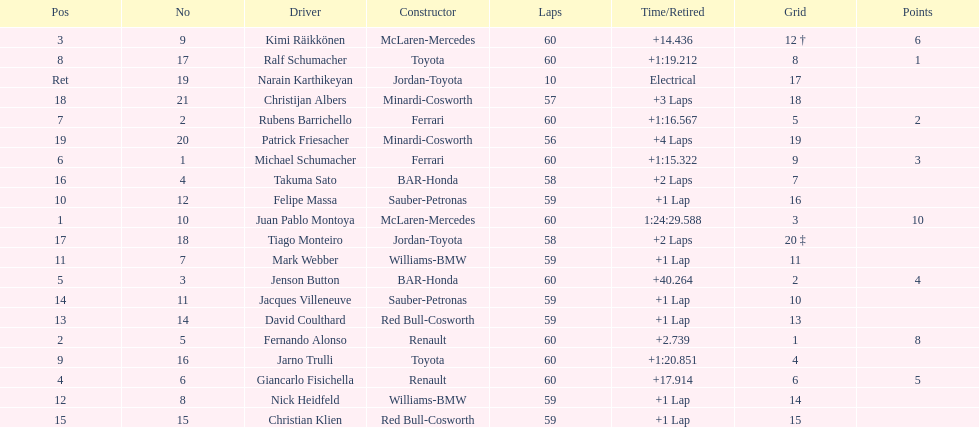What is the number of toyota's on the list? 4. Can you give me this table as a dict? {'header': ['Pos', 'No', 'Driver', 'Constructor', 'Laps', 'Time/Retired', 'Grid', 'Points'], 'rows': [['3', '9', 'Kimi Räikkönen', 'McLaren-Mercedes', '60', '+14.436', '12 †', '6'], ['8', '17', 'Ralf Schumacher', 'Toyota', '60', '+1:19.212', '8', '1'], ['Ret', '19', 'Narain Karthikeyan', 'Jordan-Toyota', '10', 'Electrical', '17', ''], ['18', '21', 'Christijan Albers', 'Minardi-Cosworth', '57', '+3 Laps', '18', ''], ['7', '2', 'Rubens Barrichello', 'Ferrari', '60', '+1:16.567', '5', '2'], ['19', '20', 'Patrick Friesacher', 'Minardi-Cosworth', '56', '+4 Laps', '19', ''], ['6', '1', 'Michael Schumacher', 'Ferrari', '60', '+1:15.322', '9', '3'], ['16', '4', 'Takuma Sato', 'BAR-Honda', '58', '+2 Laps', '7', ''], ['10', '12', 'Felipe Massa', 'Sauber-Petronas', '59', '+1 Lap', '16', ''], ['1', '10', 'Juan Pablo Montoya', 'McLaren-Mercedes', '60', '1:24:29.588', '3', '10'], ['17', '18', 'Tiago Monteiro', 'Jordan-Toyota', '58', '+2 Laps', '20 ‡', ''], ['11', '7', 'Mark Webber', 'Williams-BMW', '59', '+1 Lap', '11', ''], ['5', '3', 'Jenson Button', 'BAR-Honda', '60', '+40.264', '2', '4'], ['14', '11', 'Jacques Villeneuve', 'Sauber-Petronas', '59', '+1 Lap', '10', ''], ['13', '14', 'David Coulthard', 'Red Bull-Cosworth', '59', '+1 Lap', '13', ''], ['2', '5', 'Fernando Alonso', 'Renault', '60', '+2.739', '1', '8'], ['9', '16', 'Jarno Trulli', 'Toyota', '60', '+1:20.851', '4', ''], ['4', '6', 'Giancarlo Fisichella', 'Renault', '60', '+17.914', '6', '5'], ['12', '8', 'Nick Heidfeld', 'Williams-BMW', '59', '+1 Lap', '14', ''], ['15', '15', 'Christian Klien', 'Red Bull-Cosworth', '59', '+1 Lap', '15', '']]} 